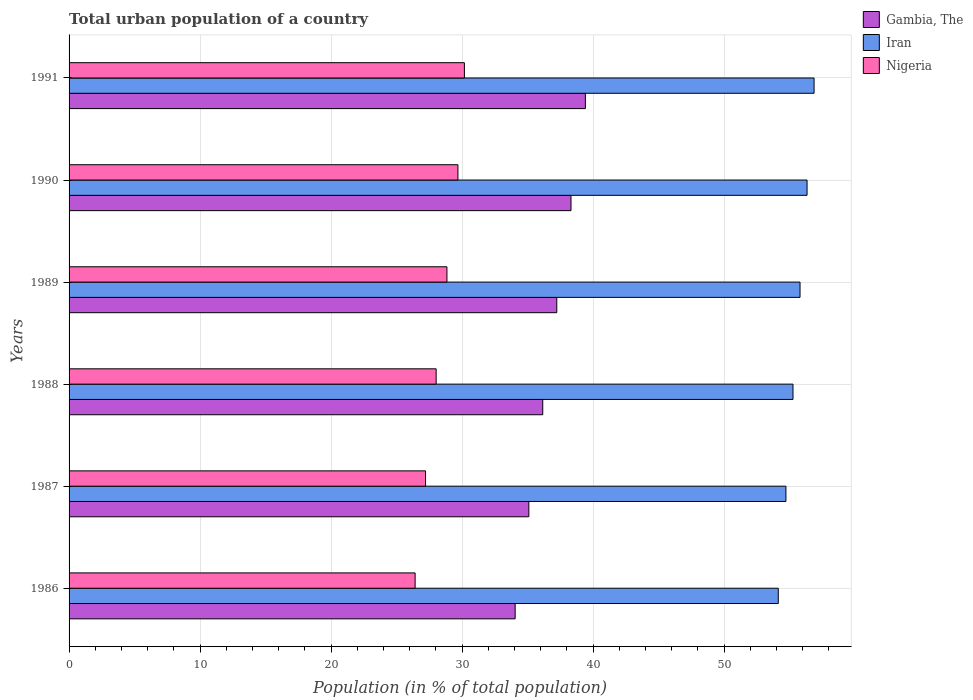How many groups of bars are there?
Your answer should be compact. 6. Are the number of bars per tick equal to the number of legend labels?
Your response must be concise. Yes. Are the number of bars on each tick of the Y-axis equal?
Make the answer very short. Yes. How many bars are there on the 4th tick from the top?
Make the answer very short. 3. What is the label of the 1st group of bars from the top?
Provide a succinct answer. 1991. In how many cases, is the number of bars for a given year not equal to the number of legend labels?
Offer a terse response. 0. What is the urban population in Iran in 1991?
Ensure brevity in your answer.  56.87. Across all years, what is the maximum urban population in Gambia, The?
Provide a short and direct response. 39.41. Across all years, what is the minimum urban population in Iran?
Your answer should be very brief. 54.13. In which year was the urban population in Iran minimum?
Keep it short and to the point. 1986. What is the total urban population in Nigeria in the graph?
Provide a succinct answer. 170.34. What is the difference between the urban population in Nigeria in 1988 and that in 1991?
Provide a succinct answer. -2.16. What is the difference between the urban population in Nigeria in 1990 and the urban population in Iran in 1989?
Offer a very short reply. -26.11. What is the average urban population in Iran per year?
Provide a succinct answer. 55.52. In the year 1987, what is the difference between the urban population in Nigeria and urban population in Iran?
Offer a very short reply. -27.51. In how many years, is the urban population in Iran greater than 10 %?
Keep it short and to the point. 6. What is the ratio of the urban population in Gambia, The in 1988 to that in 1989?
Make the answer very short. 0.97. Is the difference between the urban population in Nigeria in 1987 and 1991 greater than the difference between the urban population in Iran in 1987 and 1991?
Give a very brief answer. No. What is the difference between the highest and the second highest urban population in Gambia, The?
Provide a succinct answer. 1.1. What is the difference between the highest and the lowest urban population in Gambia, The?
Your answer should be very brief. 5.36. In how many years, is the urban population in Nigeria greater than the average urban population in Nigeria taken over all years?
Make the answer very short. 3. Is the sum of the urban population in Nigeria in 1986 and 1987 greater than the maximum urban population in Iran across all years?
Give a very brief answer. No. What does the 1st bar from the top in 1986 represents?
Provide a succinct answer. Nigeria. What does the 1st bar from the bottom in 1987 represents?
Make the answer very short. Gambia, The. How many bars are there?
Provide a succinct answer. 18. Are all the bars in the graph horizontal?
Provide a short and direct response. Yes. What is the difference between two consecutive major ticks on the X-axis?
Give a very brief answer. 10. Does the graph contain any zero values?
Provide a short and direct response. No. Does the graph contain grids?
Give a very brief answer. Yes. Where does the legend appear in the graph?
Give a very brief answer. Top right. How are the legend labels stacked?
Keep it short and to the point. Vertical. What is the title of the graph?
Offer a very short reply. Total urban population of a country. Does "Gambia, The" appear as one of the legend labels in the graph?
Your answer should be compact. Yes. What is the label or title of the X-axis?
Ensure brevity in your answer.  Population (in % of total population). What is the Population (in % of total population) in Gambia, The in 1986?
Keep it short and to the point. 34.05. What is the Population (in % of total population) of Iran in 1986?
Keep it short and to the point. 54.13. What is the Population (in % of total population) of Nigeria in 1986?
Make the answer very short. 26.41. What is the Population (in % of total population) of Gambia, The in 1987?
Offer a terse response. 35.09. What is the Population (in % of total population) of Iran in 1987?
Give a very brief answer. 54.72. What is the Population (in % of total population) in Nigeria in 1987?
Offer a very short reply. 27.21. What is the Population (in % of total population) of Gambia, The in 1988?
Offer a very short reply. 36.16. What is the Population (in % of total population) in Iran in 1988?
Your answer should be compact. 55.26. What is the Population (in % of total population) in Nigeria in 1988?
Your answer should be very brief. 28.02. What is the Population (in % of total population) in Gambia, The in 1989?
Offer a very short reply. 37.23. What is the Population (in % of total population) in Iran in 1989?
Provide a succinct answer. 55.79. What is the Population (in % of total population) in Nigeria in 1989?
Your response must be concise. 28.84. What is the Population (in % of total population) in Gambia, The in 1990?
Provide a short and direct response. 38.31. What is the Population (in % of total population) in Iran in 1990?
Keep it short and to the point. 56.33. What is the Population (in % of total population) in Nigeria in 1990?
Ensure brevity in your answer.  29.68. What is the Population (in % of total population) of Gambia, The in 1991?
Offer a very short reply. 39.41. What is the Population (in % of total population) in Iran in 1991?
Your answer should be very brief. 56.87. What is the Population (in % of total population) in Nigeria in 1991?
Ensure brevity in your answer.  30.18. Across all years, what is the maximum Population (in % of total population) in Gambia, The?
Ensure brevity in your answer.  39.41. Across all years, what is the maximum Population (in % of total population) in Iran?
Keep it short and to the point. 56.87. Across all years, what is the maximum Population (in % of total population) of Nigeria?
Provide a succinct answer. 30.18. Across all years, what is the minimum Population (in % of total population) of Gambia, The?
Offer a very short reply. 34.05. Across all years, what is the minimum Population (in % of total population) in Iran?
Make the answer very short. 54.13. Across all years, what is the minimum Population (in % of total population) of Nigeria?
Your response must be concise. 26.41. What is the total Population (in % of total population) in Gambia, The in the graph?
Give a very brief answer. 220.25. What is the total Population (in % of total population) of Iran in the graph?
Give a very brief answer. 333.1. What is the total Population (in % of total population) in Nigeria in the graph?
Make the answer very short. 170.34. What is the difference between the Population (in % of total population) of Gambia, The in 1986 and that in 1987?
Give a very brief answer. -1.04. What is the difference between the Population (in % of total population) in Iran in 1986 and that in 1987?
Offer a very short reply. -0.58. What is the difference between the Population (in % of total population) in Nigeria in 1986 and that in 1987?
Make the answer very short. -0.8. What is the difference between the Population (in % of total population) in Gambia, The in 1986 and that in 1988?
Provide a short and direct response. -2.11. What is the difference between the Population (in % of total population) in Iran in 1986 and that in 1988?
Give a very brief answer. -1.12. What is the difference between the Population (in % of total population) of Nigeria in 1986 and that in 1988?
Ensure brevity in your answer.  -1.6. What is the difference between the Population (in % of total population) in Gambia, The in 1986 and that in 1989?
Keep it short and to the point. -3.18. What is the difference between the Population (in % of total population) in Iran in 1986 and that in 1989?
Make the answer very short. -1.66. What is the difference between the Population (in % of total population) of Nigeria in 1986 and that in 1989?
Offer a very short reply. -2.43. What is the difference between the Population (in % of total population) of Gambia, The in 1986 and that in 1990?
Make the answer very short. -4.26. What is the difference between the Population (in % of total population) in Iran in 1986 and that in 1990?
Offer a very short reply. -2.2. What is the difference between the Population (in % of total population) in Nigeria in 1986 and that in 1990?
Make the answer very short. -3.27. What is the difference between the Population (in % of total population) of Gambia, The in 1986 and that in 1991?
Your response must be concise. -5.36. What is the difference between the Population (in % of total population) in Iran in 1986 and that in 1991?
Offer a terse response. -2.73. What is the difference between the Population (in % of total population) in Nigeria in 1986 and that in 1991?
Your response must be concise. -3.76. What is the difference between the Population (in % of total population) of Gambia, The in 1987 and that in 1988?
Your answer should be very brief. -1.06. What is the difference between the Population (in % of total population) in Iran in 1987 and that in 1988?
Your response must be concise. -0.54. What is the difference between the Population (in % of total population) in Nigeria in 1987 and that in 1988?
Keep it short and to the point. -0.81. What is the difference between the Population (in % of total population) of Gambia, The in 1987 and that in 1989?
Offer a terse response. -2.13. What is the difference between the Population (in % of total population) of Iran in 1987 and that in 1989?
Make the answer very short. -1.08. What is the difference between the Population (in % of total population) of Nigeria in 1987 and that in 1989?
Offer a terse response. -1.63. What is the difference between the Population (in % of total population) in Gambia, The in 1987 and that in 1990?
Provide a short and direct response. -3.22. What is the difference between the Population (in % of total population) of Iran in 1987 and that in 1990?
Offer a very short reply. -1.61. What is the difference between the Population (in % of total population) in Nigeria in 1987 and that in 1990?
Give a very brief answer. -2.47. What is the difference between the Population (in % of total population) of Gambia, The in 1987 and that in 1991?
Your answer should be compact. -4.32. What is the difference between the Population (in % of total population) of Iran in 1987 and that in 1991?
Keep it short and to the point. -2.15. What is the difference between the Population (in % of total population) of Nigeria in 1987 and that in 1991?
Provide a short and direct response. -2.97. What is the difference between the Population (in % of total population) of Gambia, The in 1988 and that in 1989?
Offer a very short reply. -1.07. What is the difference between the Population (in % of total population) of Iran in 1988 and that in 1989?
Offer a terse response. -0.54. What is the difference between the Population (in % of total population) of Nigeria in 1988 and that in 1989?
Give a very brief answer. -0.82. What is the difference between the Population (in % of total population) of Gambia, The in 1988 and that in 1990?
Your answer should be very brief. -2.16. What is the difference between the Population (in % of total population) in Iran in 1988 and that in 1990?
Your answer should be compact. -1.07. What is the difference between the Population (in % of total population) of Nigeria in 1988 and that in 1990?
Offer a very short reply. -1.66. What is the difference between the Population (in % of total population) in Gambia, The in 1988 and that in 1991?
Offer a very short reply. -3.25. What is the difference between the Population (in % of total population) in Iran in 1988 and that in 1991?
Provide a short and direct response. -1.61. What is the difference between the Population (in % of total population) of Nigeria in 1988 and that in 1991?
Offer a terse response. -2.16. What is the difference between the Population (in % of total population) in Gambia, The in 1989 and that in 1990?
Your answer should be compact. -1.09. What is the difference between the Population (in % of total population) in Iran in 1989 and that in 1990?
Make the answer very short. -0.54. What is the difference between the Population (in % of total population) in Nigeria in 1989 and that in 1990?
Keep it short and to the point. -0.84. What is the difference between the Population (in % of total population) in Gambia, The in 1989 and that in 1991?
Your answer should be compact. -2.18. What is the difference between the Population (in % of total population) of Iran in 1989 and that in 1991?
Ensure brevity in your answer.  -1.07. What is the difference between the Population (in % of total population) in Nigeria in 1989 and that in 1991?
Offer a terse response. -1.33. What is the difference between the Population (in % of total population) in Gambia, The in 1990 and that in 1991?
Your answer should be compact. -1.1. What is the difference between the Population (in % of total population) of Iran in 1990 and that in 1991?
Provide a short and direct response. -0.54. What is the difference between the Population (in % of total population) in Nigeria in 1990 and that in 1991?
Provide a short and direct response. -0.5. What is the difference between the Population (in % of total population) in Gambia, The in 1986 and the Population (in % of total population) in Iran in 1987?
Make the answer very short. -20.67. What is the difference between the Population (in % of total population) of Gambia, The in 1986 and the Population (in % of total population) of Nigeria in 1987?
Provide a short and direct response. 6.84. What is the difference between the Population (in % of total population) in Iran in 1986 and the Population (in % of total population) in Nigeria in 1987?
Your response must be concise. 26.92. What is the difference between the Population (in % of total population) of Gambia, The in 1986 and the Population (in % of total population) of Iran in 1988?
Ensure brevity in your answer.  -21.21. What is the difference between the Population (in % of total population) in Gambia, The in 1986 and the Population (in % of total population) in Nigeria in 1988?
Offer a very short reply. 6.03. What is the difference between the Population (in % of total population) in Iran in 1986 and the Population (in % of total population) in Nigeria in 1988?
Provide a short and direct response. 26.11. What is the difference between the Population (in % of total population) of Gambia, The in 1986 and the Population (in % of total population) of Iran in 1989?
Offer a very short reply. -21.75. What is the difference between the Population (in % of total population) of Gambia, The in 1986 and the Population (in % of total population) of Nigeria in 1989?
Offer a terse response. 5.21. What is the difference between the Population (in % of total population) in Iran in 1986 and the Population (in % of total population) in Nigeria in 1989?
Provide a short and direct response. 25.29. What is the difference between the Population (in % of total population) of Gambia, The in 1986 and the Population (in % of total population) of Iran in 1990?
Offer a terse response. -22.28. What is the difference between the Population (in % of total population) in Gambia, The in 1986 and the Population (in % of total population) in Nigeria in 1990?
Provide a succinct answer. 4.37. What is the difference between the Population (in % of total population) in Iran in 1986 and the Population (in % of total population) in Nigeria in 1990?
Keep it short and to the point. 24.45. What is the difference between the Population (in % of total population) in Gambia, The in 1986 and the Population (in % of total population) in Iran in 1991?
Keep it short and to the point. -22.82. What is the difference between the Population (in % of total population) of Gambia, The in 1986 and the Population (in % of total population) of Nigeria in 1991?
Give a very brief answer. 3.87. What is the difference between the Population (in % of total population) in Iran in 1986 and the Population (in % of total population) in Nigeria in 1991?
Your answer should be very brief. 23.96. What is the difference between the Population (in % of total population) in Gambia, The in 1987 and the Population (in % of total population) in Iran in 1988?
Provide a succinct answer. -20.16. What is the difference between the Population (in % of total population) of Gambia, The in 1987 and the Population (in % of total population) of Nigeria in 1988?
Your response must be concise. 7.08. What is the difference between the Population (in % of total population) in Iran in 1987 and the Population (in % of total population) in Nigeria in 1988?
Your response must be concise. 26.7. What is the difference between the Population (in % of total population) of Gambia, The in 1987 and the Population (in % of total population) of Iran in 1989?
Ensure brevity in your answer.  -20.7. What is the difference between the Population (in % of total population) in Gambia, The in 1987 and the Population (in % of total population) in Nigeria in 1989?
Provide a short and direct response. 6.25. What is the difference between the Population (in % of total population) of Iran in 1987 and the Population (in % of total population) of Nigeria in 1989?
Your answer should be compact. 25.88. What is the difference between the Population (in % of total population) in Gambia, The in 1987 and the Population (in % of total population) in Iran in 1990?
Give a very brief answer. -21.24. What is the difference between the Population (in % of total population) in Gambia, The in 1987 and the Population (in % of total population) in Nigeria in 1990?
Your answer should be very brief. 5.41. What is the difference between the Population (in % of total population) of Iran in 1987 and the Population (in % of total population) of Nigeria in 1990?
Provide a short and direct response. 25.04. What is the difference between the Population (in % of total population) in Gambia, The in 1987 and the Population (in % of total population) in Iran in 1991?
Give a very brief answer. -21.77. What is the difference between the Population (in % of total population) in Gambia, The in 1987 and the Population (in % of total population) in Nigeria in 1991?
Your answer should be very brief. 4.92. What is the difference between the Population (in % of total population) in Iran in 1987 and the Population (in % of total population) in Nigeria in 1991?
Offer a very short reply. 24.54. What is the difference between the Population (in % of total population) in Gambia, The in 1988 and the Population (in % of total population) in Iran in 1989?
Offer a very short reply. -19.64. What is the difference between the Population (in % of total population) in Gambia, The in 1988 and the Population (in % of total population) in Nigeria in 1989?
Your answer should be very brief. 7.31. What is the difference between the Population (in % of total population) in Iran in 1988 and the Population (in % of total population) in Nigeria in 1989?
Give a very brief answer. 26.41. What is the difference between the Population (in % of total population) in Gambia, The in 1988 and the Population (in % of total population) in Iran in 1990?
Offer a very short reply. -20.18. What is the difference between the Population (in % of total population) of Gambia, The in 1988 and the Population (in % of total population) of Nigeria in 1990?
Your answer should be very brief. 6.47. What is the difference between the Population (in % of total population) of Iran in 1988 and the Population (in % of total population) of Nigeria in 1990?
Offer a terse response. 25.58. What is the difference between the Population (in % of total population) in Gambia, The in 1988 and the Population (in % of total population) in Iran in 1991?
Ensure brevity in your answer.  -20.71. What is the difference between the Population (in % of total population) of Gambia, The in 1988 and the Population (in % of total population) of Nigeria in 1991?
Make the answer very short. 5.98. What is the difference between the Population (in % of total population) of Iran in 1988 and the Population (in % of total population) of Nigeria in 1991?
Make the answer very short. 25.08. What is the difference between the Population (in % of total population) in Gambia, The in 1989 and the Population (in % of total population) in Iran in 1990?
Make the answer very short. -19.1. What is the difference between the Population (in % of total population) of Gambia, The in 1989 and the Population (in % of total population) of Nigeria in 1990?
Provide a succinct answer. 7.55. What is the difference between the Population (in % of total population) of Iran in 1989 and the Population (in % of total population) of Nigeria in 1990?
Your answer should be compact. 26.11. What is the difference between the Population (in % of total population) in Gambia, The in 1989 and the Population (in % of total population) in Iran in 1991?
Offer a terse response. -19.64. What is the difference between the Population (in % of total population) of Gambia, The in 1989 and the Population (in % of total population) of Nigeria in 1991?
Your answer should be very brief. 7.05. What is the difference between the Population (in % of total population) in Iran in 1989 and the Population (in % of total population) in Nigeria in 1991?
Offer a terse response. 25.62. What is the difference between the Population (in % of total population) of Gambia, The in 1990 and the Population (in % of total population) of Iran in 1991?
Keep it short and to the point. -18.55. What is the difference between the Population (in % of total population) of Gambia, The in 1990 and the Population (in % of total population) of Nigeria in 1991?
Your answer should be compact. 8.14. What is the difference between the Population (in % of total population) of Iran in 1990 and the Population (in % of total population) of Nigeria in 1991?
Give a very brief answer. 26.15. What is the average Population (in % of total population) of Gambia, The per year?
Your answer should be compact. 36.71. What is the average Population (in % of total population) of Iran per year?
Make the answer very short. 55.52. What is the average Population (in % of total population) in Nigeria per year?
Provide a short and direct response. 28.39. In the year 1986, what is the difference between the Population (in % of total population) of Gambia, The and Population (in % of total population) of Iran?
Your answer should be very brief. -20.08. In the year 1986, what is the difference between the Population (in % of total population) of Gambia, The and Population (in % of total population) of Nigeria?
Provide a succinct answer. 7.63. In the year 1986, what is the difference between the Population (in % of total population) of Iran and Population (in % of total population) of Nigeria?
Your answer should be very brief. 27.72. In the year 1987, what is the difference between the Population (in % of total population) in Gambia, The and Population (in % of total population) in Iran?
Offer a terse response. -19.62. In the year 1987, what is the difference between the Population (in % of total population) in Gambia, The and Population (in % of total population) in Nigeria?
Your answer should be very brief. 7.88. In the year 1987, what is the difference between the Population (in % of total population) in Iran and Population (in % of total population) in Nigeria?
Provide a succinct answer. 27.51. In the year 1988, what is the difference between the Population (in % of total population) in Gambia, The and Population (in % of total population) in Iran?
Keep it short and to the point. -19.1. In the year 1988, what is the difference between the Population (in % of total population) of Gambia, The and Population (in % of total population) of Nigeria?
Provide a succinct answer. 8.14. In the year 1988, what is the difference between the Population (in % of total population) of Iran and Population (in % of total population) of Nigeria?
Ensure brevity in your answer.  27.24. In the year 1989, what is the difference between the Population (in % of total population) in Gambia, The and Population (in % of total population) in Iran?
Give a very brief answer. -18.57. In the year 1989, what is the difference between the Population (in % of total population) in Gambia, The and Population (in % of total population) in Nigeria?
Offer a terse response. 8.38. In the year 1989, what is the difference between the Population (in % of total population) in Iran and Population (in % of total population) in Nigeria?
Your answer should be very brief. 26.95. In the year 1990, what is the difference between the Population (in % of total population) in Gambia, The and Population (in % of total population) in Iran?
Provide a short and direct response. -18.02. In the year 1990, what is the difference between the Population (in % of total population) in Gambia, The and Population (in % of total population) in Nigeria?
Ensure brevity in your answer.  8.63. In the year 1990, what is the difference between the Population (in % of total population) of Iran and Population (in % of total population) of Nigeria?
Keep it short and to the point. 26.65. In the year 1991, what is the difference between the Population (in % of total population) in Gambia, The and Population (in % of total population) in Iran?
Give a very brief answer. -17.45. In the year 1991, what is the difference between the Population (in % of total population) in Gambia, The and Population (in % of total population) in Nigeria?
Give a very brief answer. 9.23. In the year 1991, what is the difference between the Population (in % of total population) of Iran and Population (in % of total population) of Nigeria?
Offer a terse response. 26.69. What is the ratio of the Population (in % of total population) of Gambia, The in 1986 to that in 1987?
Provide a short and direct response. 0.97. What is the ratio of the Population (in % of total population) of Iran in 1986 to that in 1987?
Offer a very short reply. 0.99. What is the ratio of the Population (in % of total population) in Nigeria in 1986 to that in 1987?
Provide a short and direct response. 0.97. What is the ratio of the Population (in % of total population) in Gambia, The in 1986 to that in 1988?
Make the answer very short. 0.94. What is the ratio of the Population (in % of total population) in Iran in 1986 to that in 1988?
Your answer should be compact. 0.98. What is the ratio of the Population (in % of total population) in Nigeria in 1986 to that in 1988?
Give a very brief answer. 0.94. What is the ratio of the Population (in % of total population) of Gambia, The in 1986 to that in 1989?
Provide a succinct answer. 0.91. What is the ratio of the Population (in % of total population) of Iran in 1986 to that in 1989?
Make the answer very short. 0.97. What is the ratio of the Population (in % of total population) in Nigeria in 1986 to that in 1989?
Ensure brevity in your answer.  0.92. What is the ratio of the Population (in % of total population) of Gambia, The in 1986 to that in 1990?
Make the answer very short. 0.89. What is the ratio of the Population (in % of total population) of Iran in 1986 to that in 1990?
Offer a terse response. 0.96. What is the ratio of the Population (in % of total population) in Nigeria in 1986 to that in 1990?
Offer a terse response. 0.89. What is the ratio of the Population (in % of total population) of Gambia, The in 1986 to that in 1991?
Your answer should be very brief. 0.86. What is the ratio of the Population (in % of total population) of Iran in 1986 to that in 1991?
Make the answer very short. 0.95. What is the ratio of the Population (in % of total population) in Nigeria in 1986 to that in 1991?
Your answer should be very brief. 0.88. What is the ratio of the Population (in % of total population) of Gambia, The in 1987 to that in 1988?
Your answer should be compact. 0.97. What is the ratio of the Population (in % of total population) of Iran in 1987 to that in 1988?
Offer a terse response. 0.99. What is the ratio of the Population (in % of total population) of Nigeria in 1987 to that in 1988?
Offer a terse response. 0.97. What is the ratio of the Population (in % of total population) of Gambia, The in 1987 to that in 1989?
Offer a terse response. 0.94. What is the ratio of the Population (in % of total population) of Iran in 1987 to that in 1989?
Your answer should be compact. 0.98. What is the ratio of the Population (in % of total population) of Nigeria in 1987 to that in 1989?
Your response must be concise. 0.94. What is the ratio of the Population (in % of total population) of Gambia, The in 1987 to that in 1990?
Offer a terse response. 0.92. What is the ratio of the Population (in % of total population) of Iran in 1987 to that in 1990?
Ensure brevity in your answer.  0.97. What is the ratio of the Population (in % of total population) in Nigeria in 1987 to that in 1990?
Offer a very short reply. 0.92. What is the ratio of the Population (in % of total population) of Gambia, The in 1987 to that in 1991?
Your answer should be very brief. 0.89. What is the ratio of the Population (in % of total population) of Iran in 1987 to that in 1991?
Offer a very short reply. 0.96. What is the ratio of the Population (in % of total population) of Nigeria in 1987 to that in 1991?
Keep it short and to the point. 0.9. What is the ratio of the Population (in % of total population) of Gambia, The in 1988 to that in 1989?
Give a very brief answer. 0.97. What is the ratio of the Population (in % of total population) in Nigeria in 1988 to that in 1989?
Keep it short and to the point. 0.97. What is the ratio of the Population (in % of total population) in Gambia, The in 1988 to that in 1990?
Your answer should be compact. 0.94. What is the ratio of the Population (in % of total population) in Nigeria in 1988 to that in 1990?
Your response must be concise. 0.94. What is the ratio of the Population (in % of total population) in Gambia, The in 1988 to that in 1991?
Make the answer very short. 0.92. What is the ratio of the Population (in % of total population) of Iran in 1988 to that in 1991?
Ensure brevity in your answer.  0.97. What is the ratio of the Population (in % of total population) in Nigeria in 1988 to that in 1991?
Your response must be concise. 0.93. What is the ratio of the Population (in % of total population) in Gambia, The in 1989 to that in 1990?
Offer a terse response. 0.97. What is the ratio of the Population (in % of total population) of Iran in 1989 to that in 1990?
Your answer should be compact. 0.99. What is the ratio of the Population (in % of total population) in Nigeria in 1989 to that in 1990?
Give a very brief answer. 0.97. What is the ratio of the Population (in % of total population) in Gambia, The in 1989 to that in 1991?
Your answer should be very brief. 0.94. What is the ratio of the Population (in % of total population) in Iran in 1989 to that in 1991?
Offer a terse response. 0.98. What is the ratio of the Population (in % of total population) of Nigeria in 1989 to that in 1991?
Give a very brief answer. 0.96. What is the ratio of the Population (in % of total population) of Gambia, The in 1990 to that in 1991?
Ensure brevity in your answer.  0.97. What is the ratio of the Population (in % of total population) in Iran in 1990 to that in 1991?
Give a very brief answer. 0.99. What is the ratio of the Population (in % of total population) of Nigeria in 1990 to that in 1991?
Your answer should be compact. 0.98. What is the difference between the highest and the second highest Population (in % of total population) of Gambia, The?
Your response must be concise. 1.1. What is the difference between the highest and the second highest Population (in % of total population) of Iran?
Provide a succinct answer. 0.54. What is the difference between the highest and the second highest Population (in % of total population) in Nigeria?
Your response must be concise. 0.5. What is the difference between the highest and the lowest Population (in % of total population) in Gambia, The?
Make the answer very short. 5.36. What is the difference between the highest and the lowest Population (in % of total population) of Iran?
Provide a succinct answer. 2.73. What is the difference between the highest and the lowest Population (in % of total population) in Nigeria?
Give a very brief answer. 3.76. 